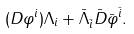Convert formula to latex. <formula><loc_0><loc_0><loc_500><loc_500>( D \varphi ^ { i } ) \Lambda _ { i } + \bar { \Lambda } _ { \bar { i } } \bar { D } \bar { \varphi } ^ { \bar { i } } .</formula> 